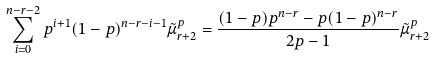<formula> <loc_0><loc_0><loc_500><loc_500>\sum _ { i = 0 } ^ { n - r - 2 } p ^ { i + 1 } ( 1 - p ) ^ { n - r - i - 1 } \tilde { \mu } _ { r + 2 } ^ { p } = \frac { ( 1 - p ) p ^ { n - r } - p ( 1 - p ) ^ { n - r } } { 2 p - 1 } \tilde { \mu } _ { r + 2 } ^ { p }</formula> 